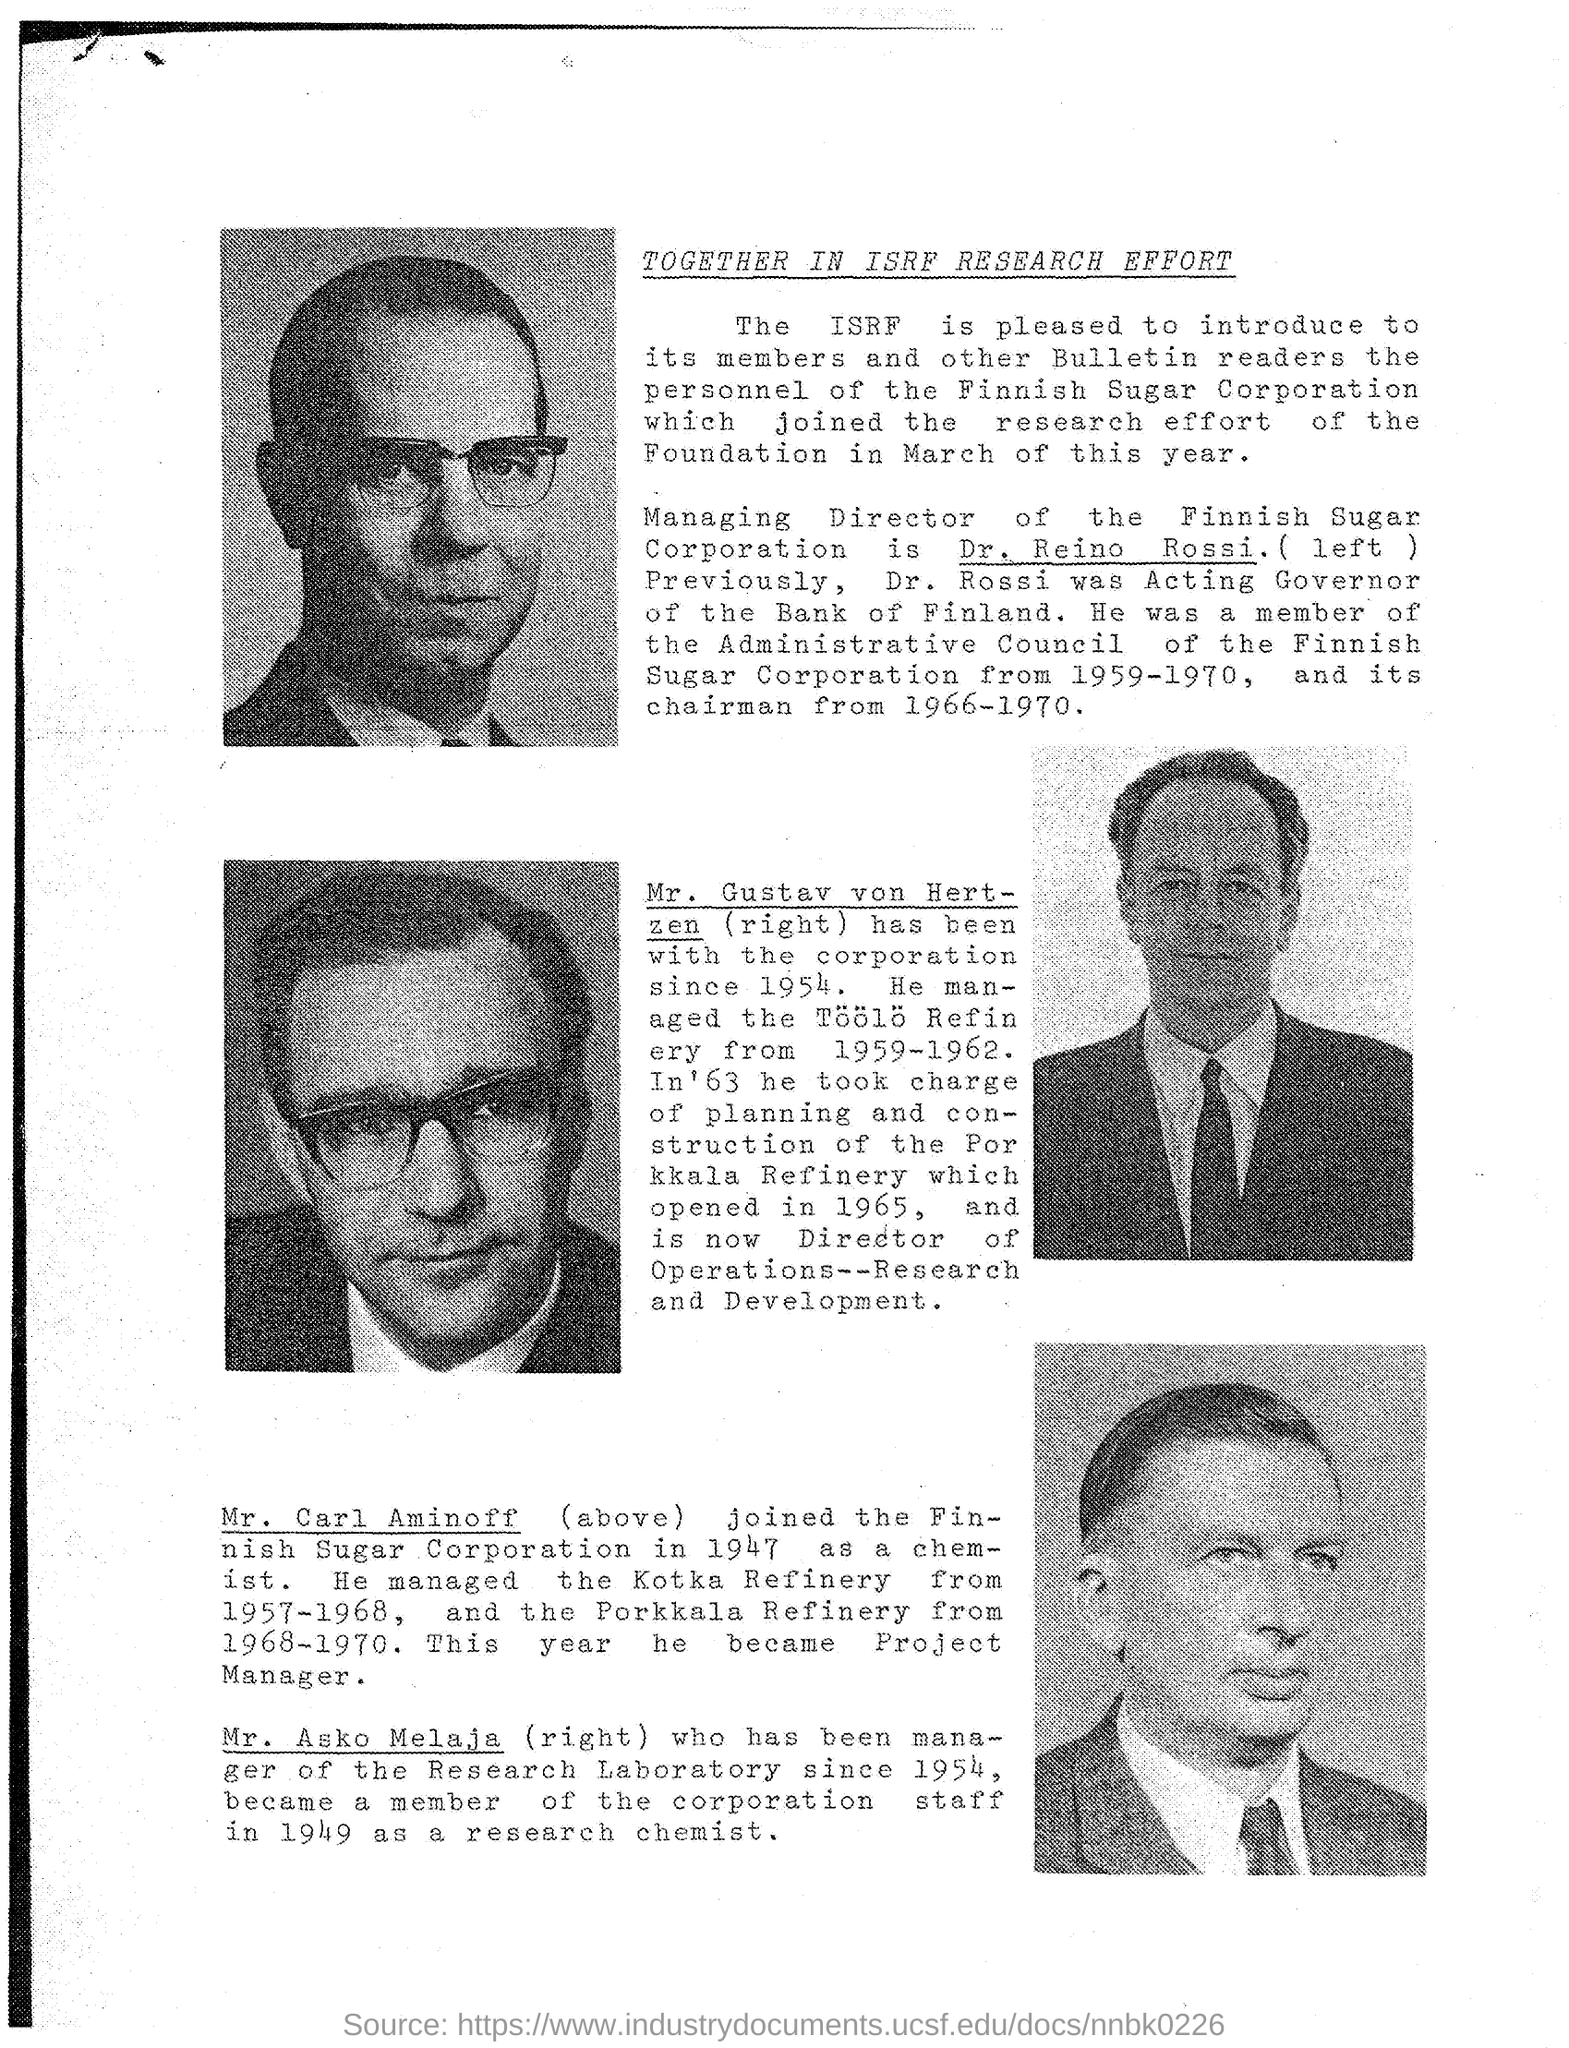What is the Title of the Document?
Your answer should be compact. Together in ISRF Research Effort. Who is the Managing Director of Finnish Sugar corporation?
Provide a short and direct response. Dr. Reino Rossi. Mr. Gustav von Hertzen has been with corporation since when?
Offer a very short reply. 1954. 